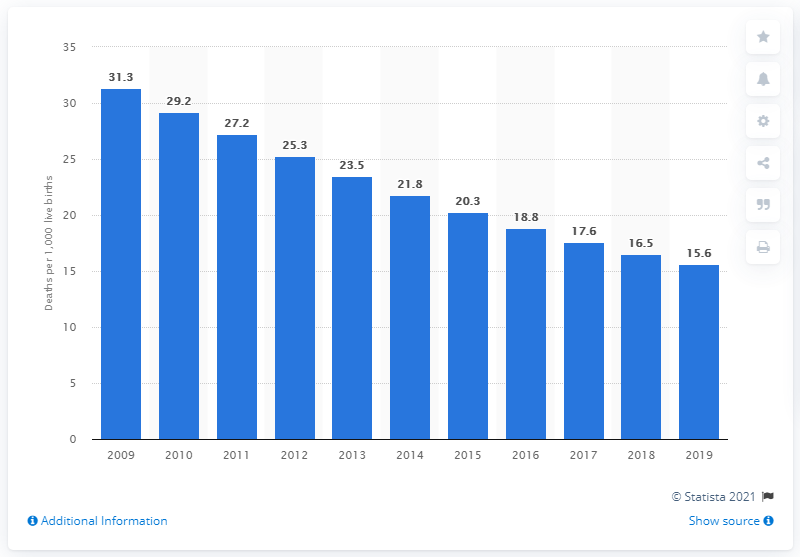Highlight a few significant elements in this photo. The infant mortality rate in Uzbekistan in 2019 was 15.6. 